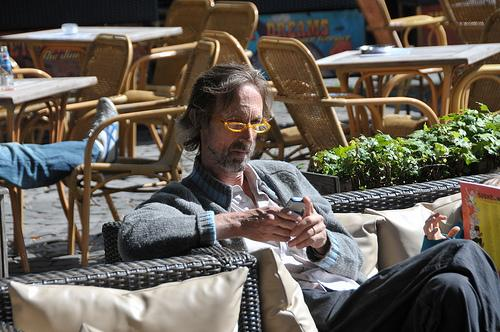What is the man wearing? Please explain your reasoning. glasses. The man has glasses. 